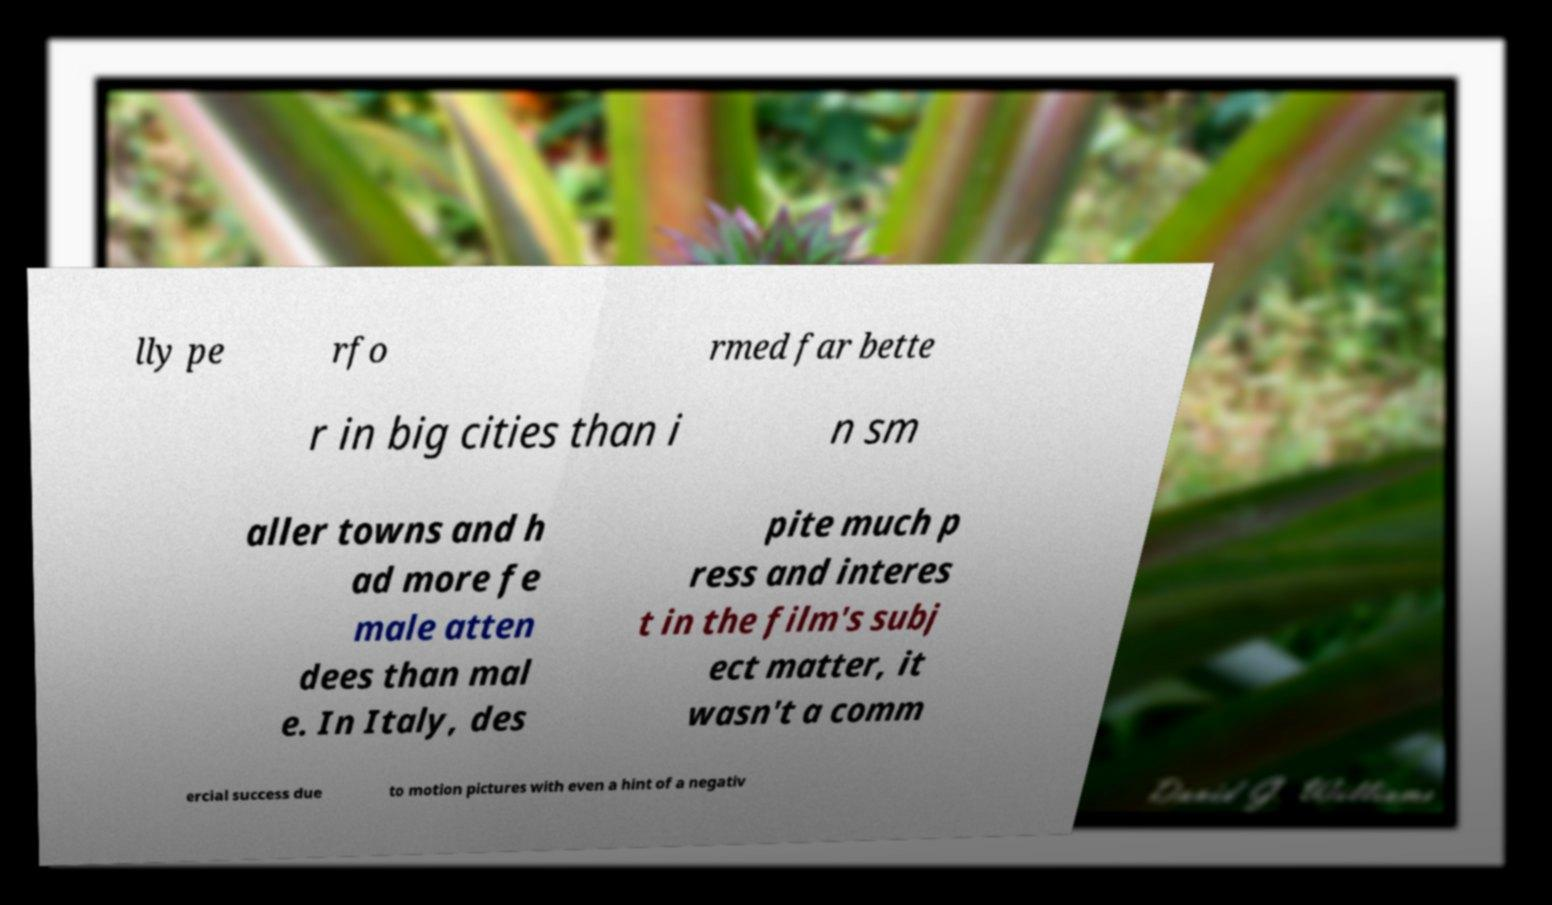Please read and relay the text visible in this image. What does it say? lly pe rfo rmed far bette r in big cities than i n sm aller towns and h ad more fe male atten dees than mal e. In Italy, des pite much p ress and interes t in the film's subj ect matter, it wasn't a comm ercial success due to motion pictures with even a hint of a negativ 